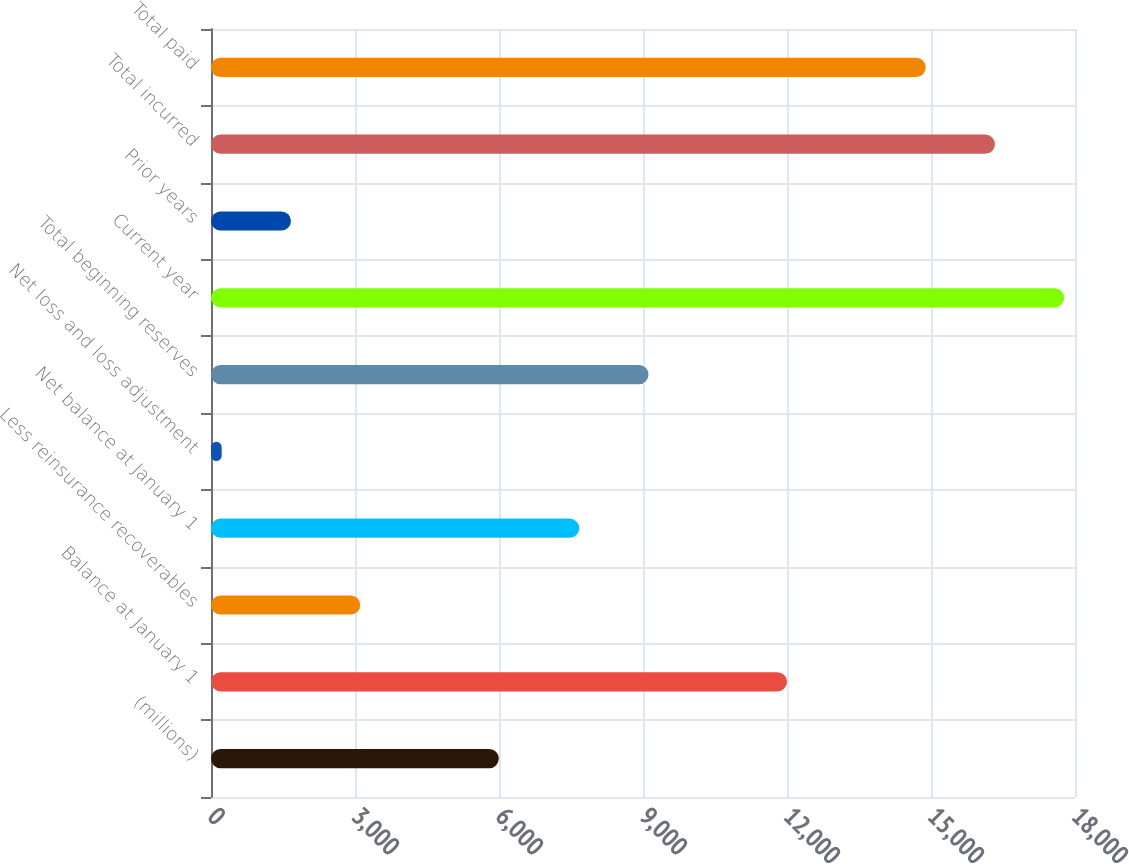<chart> <loc_0><loc_0><loc_500><loc_500><bar_chart><fcel>(millions)<fcel>Balance at January 1<fcel>Less reinsurance recoverables<fcel>Net balance at January 1<fcel>Net loss and loss adjustment<fcel>Total beginning reserves<fcel>Current year<fcel>Prior years<fcel>Total incurred<fcel>Total paid<nl><fcel>5996.28<fcel>12001.9<fcel>3109.34<fcel>7671.5<fcel>222.4<fcel>9114.97<fcel>17775.8<fcel>1665.87<fcel>16332.3<fcel>14888.9<nl></chart> 